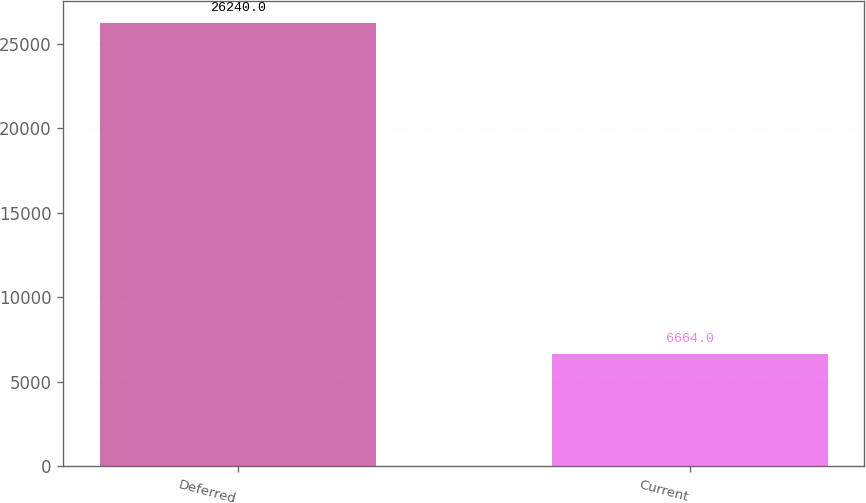<chart> <loc_0><loc_0><loc_500><loc_500><bar_chart><fcel>Deferred<fcel>Current<nl><fcel>26240<fcel>6664<nl></chart> 